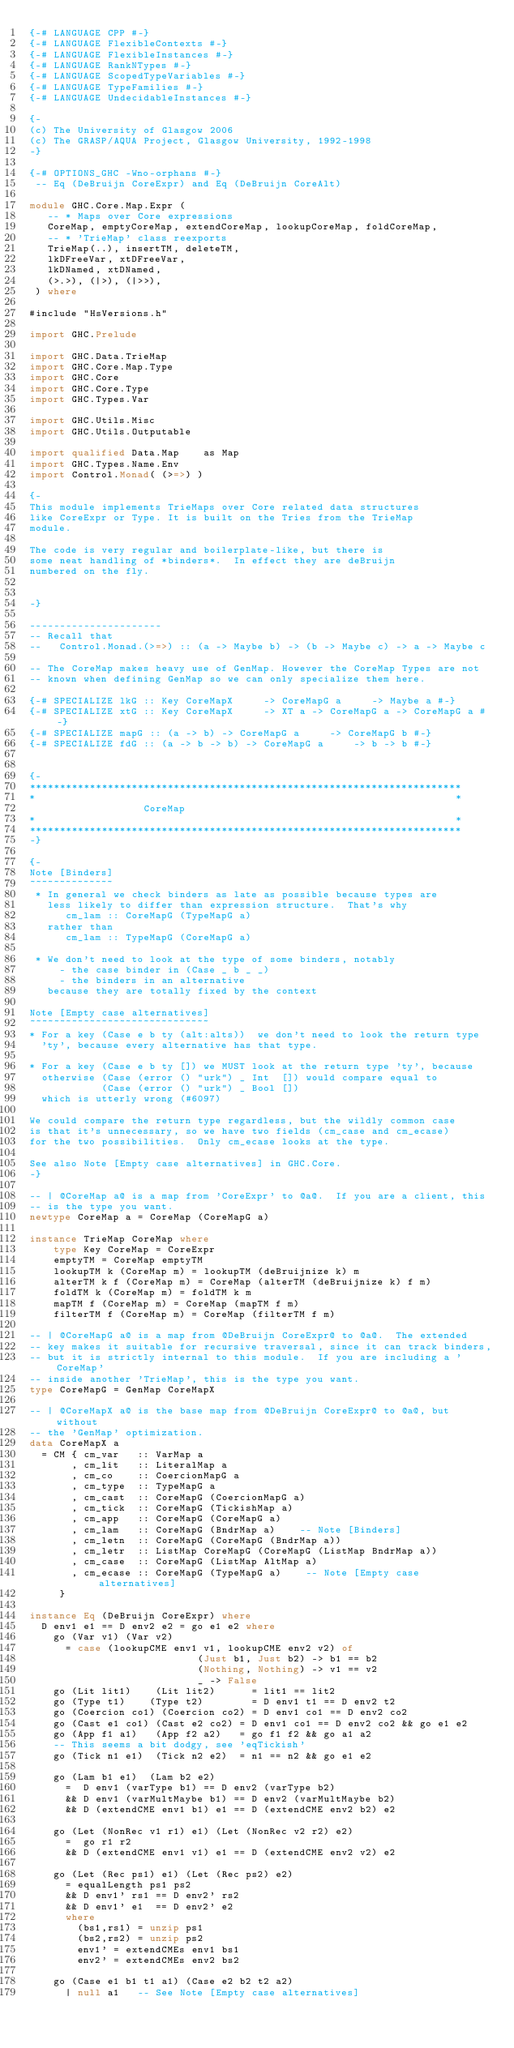<code> <loc_0><loc_0><loc_500><loc_500><_Haskell_>{-# LANGUAGE CPP #-}
{-# LANGUAGE FlexibleContexts #-}
{-# LANGUAGE FlexibleInstances #-}
{-# LANGUAGE RankNTypes #-}
{-# LANGUAGE ScopedTypeVariables #-}
{-# LANGUAGE TypeFamilies #-}
{-# LANGUAGE UndecidableInstances #-}

{-
(c) The University of Glasgow 2006
(c) The GRASP/AQUA Project, Glasgow University, 1992-1998
-}

{-# OPTIONS_GHC -Wno-orphans #-}
 -- Eq (DeBruijn CoreExpr) and Eq (DeBruijn CoreAlt)

module GHC.Core.Map.Expr (
   -- * Maps over Core expressions
   CoreMap, emptyCoreMap, extendCoreMap, lookupCoreMap, foldCoreMap,
   -- * 'TrieMap' class reexports
   TrieMap(..), insertTM, deleteTM,
   lkDFreeVar, xtDFreeVar,
   lkDNamed, xtDNamed,
   (>.>), (|>), (|>>),
 ) where

#include "HsVersions.h"

import GHC.Prelude

import GHC.Data.TrieMap
import GHC.Core.Map.Type
import GHC.Core
import GHC.Core.Type
import GHC.Types.Var

import GHC.Utils.Misc
import GHC.Utils.Outputable

import qualified Data.Map    as Map
import GHC.Types.Name.Env
import Control.Monad( (>=>) )

{-
This module implements TrieMaps over Core related data structures
like CoreExpr or Type. It is built on the Tries from the TrieMap
module.

The code is very regular and boilerplate-like, but there is
some neat handling of *binders*.  In effect they are deBruijn
numbered on the fly.


-}

----------------------
-- Recall that
--   Control.Monad.(>=>) :: (a -> Maybe b) -> (b -> Maybe c) -> a -> Maybe c

-- The CoreMap makes heavy use of GenMap. However the CoreMap Types are not
-- known when defining GenMap so we can only specialize them here.

{-# SPECIALIZE lkG :: Key CoreMapX     -> CoreMapG a     -> Maybe a #-}
{-# SPECIALIZE xtG :: Key CoreMapX     -> XT a -> CoreMapG a -> CoreMapG a #-}
{-# SPECIALIZE mapG :: (a -> b) -> CoreMapG a     -> CoreMapG b #-}
{-# SPECIALIZE fdG :: (a -> b -> b) -> CoreMapG a     -> b -> b #-}


{-
************************************************************************
*                                                                      *
                   CoreMap
*                                                                      *
************************************************************************
-}

{-
Note [Binders]
~~~~~~~~~~~~~~
 * In general we check binders as late as possible because types are
   less likely to differ than expression structure.  That's why
      cm_lam :: CoreMapG (TypeMapG a)
   rather than
      cm_lam :: TypeMapG (CoreMapG a)

 * We don't need to look at the type of some binders, notably
     - the case binder in (Case _ b _ _)
     - the binders in an alternative
   because they are totally fixed by the context

Note [Empty case alternatives]
~~~~~~~~~~~~~~~~~~~~~~~~~~~~~~
* For a key (Case e b ty (alt:alts))  we don't need to look the return type
  'ty', because every alternative has that type.

* For a key (Case e b ty []) we MUST look at the return type 'ty', because
  otherwise (Case (error () "urk") _ Int  []) would compare equal to
            (Case (error () "urk") _ Bool [])
  which is utterly wrong (#6097)

We could compare the return type regardless, but the wildly common case
is that it's unnecessary, so we have two fields (cm_case and cm_ecase)
for the two possibilities.  Only cm_ecase looks at the type.

See also Note [Empty case alternatives] in GHC.Core.
-}

-- | @CoreMap a@ is a map from 'CoreExpr' to @a@.  If you are a client, this
-- is the type you want.
newtype CoreMap a = CoreMap (CoreMapG a)

instance TrieMap CoreMap where
    type Key CoreMap = CoreExpr
    emptyTM = CoreMap emptyTM
    lookupTM k (CoreMap m) = lookupTM (deBruijnize k) m
    alterTM k f (CoreMap m) = CoreMap (alterTM (deBruijnize k) f m)
    foldTM k (CoreMap m) = foldTM k m
    mapTM f (CoreMap m) = CoreMap (mapTM f m)
    filterTM f (CoreMap m) = CoreMap (filterTM f m)

-- | @CoreMapG a@ is a map from @DeBruijn CoreExpr@ to @a@.  The extended
-- key makes it suitable for recursive traversal, since it can track binders,
-- but it is strictly internal to this module.  If you are including a 'CoreMap'
-- inside another 'TrieMap', this is the type you want.
type CoreMapG = GenMap CoreMapX

-- | @CoreMapX a@ is the base map from @DeBruijn CoreExpr@ to @a@, but without
-- the 'GenMap' optimization.
data CoreMapX a
  = CM { cm_var   :: VarMap a
       , cm_lit   :: LiteralMap a
       , cm_co    :: CoercionMapG a
       , cm_type  :: TypeMapG a
       , cm_cast  :: CoreMapG (CoercionMapG a)
       , cm_tick  :: CoreMapG (TickishMap a)
       , cm_app   :: CoreMapG (CoreMapG a)
       , cm_lam   :: CoreMapG (BndrMap a)    -- Note [Binders]
       , cm_letn  :: CoreMapG (CoreMapG (BndrMap a))
       , cm_letr  :: ListMap CoreMapG (CoreMapG (ListMap BndrMap a))
       , cm_case  :: CoreMapG (ListMap AltMap a)
       , cm_ecase :: CoreMapG (TypeMapG a)    -- Note [Empty case alternatives]
     }

instance Eq (DeBruijn CoreExpr) where
  D env1 e1 == D env2 e2 = go e1 e2 where
    go (Var v1) (Var v2)
      = case (lookupCME env1 v1, lookupCME env2 v2) of
                            (Just b1, Just b2) -> b1 == b2
                            (Nothing, Nothing) -> v1 == v2
                            _ -> False
    go (Lit lit1)    (Lit lit2)      = lit1 == lit2
    go (Type t1)    (Type t2)        = D env1 t1 == D env2 t2
    go (Coercion co1) (Coercion co2) = D env1 co1 == D env2 co2
    go (Cast e1 co1) (Cast e2 co2) = D env1 co1 == D env2 co2 && go e1 e2
    go (App f1 a1)   (App f2 a2)   = go f1 f2 && go a1 a2
    -- This seems a bit dodgy, see 'eqTickish'
    go (Tick n1 e1)  (Tick n2 e2)  = n1 == n2 && go e1 e2

    go (Lam b1 e1)  (Lam b2 e2)
      =  D env1 (varType b1) == D env2 (varType b2)
      && D env1 (varMultMaybe b1) == D env2 (varMultMaybe b2)
      && D (extendCME env1 b1) e1 == D (extendCME env2 b2) e2

    go (Let (NonRec v1 r1) e1) (Let (NonRec v2 r2) e2)
      =  go r1 r2
      && D (extendCME env1 v1) e1 == D (extendCME env2 v2) e2

    go (Let (Rec ps1) e1) (Let (Rec ps2) e2)
      = equalLength ps1 ps2
      && D env1' rs1 == D env2' rs2
      && D env1' e1  == D env2' e2
      where
        (bs1,rs1) = unzip ps1
        (bs2,rs2) = unzip ps2
        env1' = extendCMEs env1 bs1
        env2' = extendCMEs env2 bs2

    go (Case e1 b1 t1 a1) (Case e2 b2 t2 a2)
      | null a1   -- See Note [Empty case alternatives]</code> 